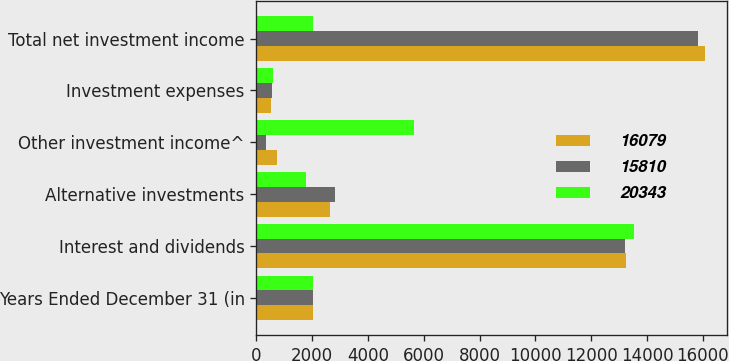<chart> <loc_0><loc_0><loc_500><loc_500><stacked_bar_chart><ecel><fcel>Years Ended December 31 (in<fcel>Interest and dividends<fcel>Alternative investments<fcel>Other investment income^<fcel>Investment expenses<fcel>Total net investment income<nl><fcel>16079<fcel>2014<fcel>13246<fcel>2624<fcel>726<fcel>517<fcel>16079<nl><fcel>15810<fcel>2013<fcel>13199<fcel>2803<fcel>356<fcel>548<fcel>15810<nl><fcel>20343<fcel>2012<fcel>13544<fcel>1769<fcel>5634<fcel>604<fcel>2014<nl></chart> 